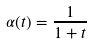<formula> <loc_0><loc_0><loc_500><loc_500>\alpha ( t ) = \frac { 1 } { 1 + t }</formula> 